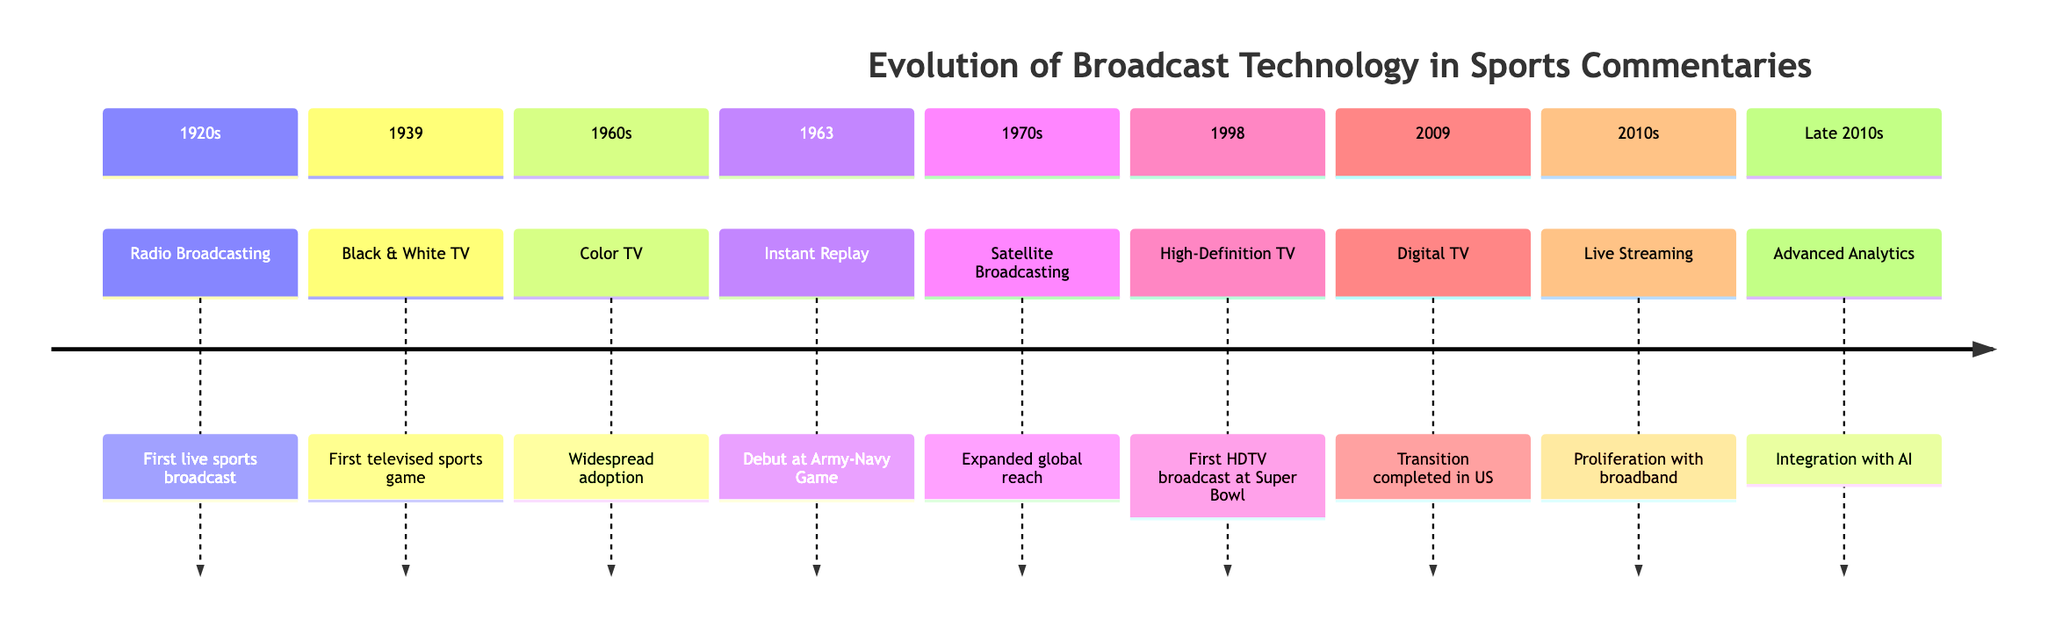What was the first form of broadcasting in sports? The timeline indicates that radio broadcasting was the first form of live sports broadcast, which occurred in the 1920s.
Answer: Radio Broadcasting Which major advancement in sports broadcasting occurred in 1939? According to the timeline, the first televised sports game marked a significant advancement in 1939, indicating the introduction of Black & White TV.
Answer: Black & White TV What noteworthy technology debuted during the Army-Navy Game in 1963? The timeline specifies that instant replay made its debut at the Army-Navy Game in 1963. This signifies a crucial development in how sports were presented.
Answer: Instant Replay In what decade did high-definition TV first broadcast during a Super Bowl? The diagram shows that high-definition TV was first broadcast during the Super Bowl in 1998, which falls in the late 90s.
Answer: 1998 How did satellite broadcasting impact sports coverage in the 1970s? The section indicates that satellite broadcasting expanded global reach in the 1970s, which improved how audiences accessed live sports.
Answer: Expanded global reach What significant transition in broadcasting technology was completed in 2009? The timeline states that the transition to digital TV was completed in 2009, marking a leap in broadcasting technology.
Answer: Digital TV Which broadcasting innovation proliferated in the 2010s? According to the timeline, live streaming became widespread during the 2010s, indicating a shift in how audiences consumed live sports.
Answer: Live Streaming What does the late 2010s represent in terms of analytics integration? The timeline denotes that advanced analytics began integrating with AI in the late 2010s, suggesting a more analytical approach to sports broadcasting.
Answer: Advanced Analytics 